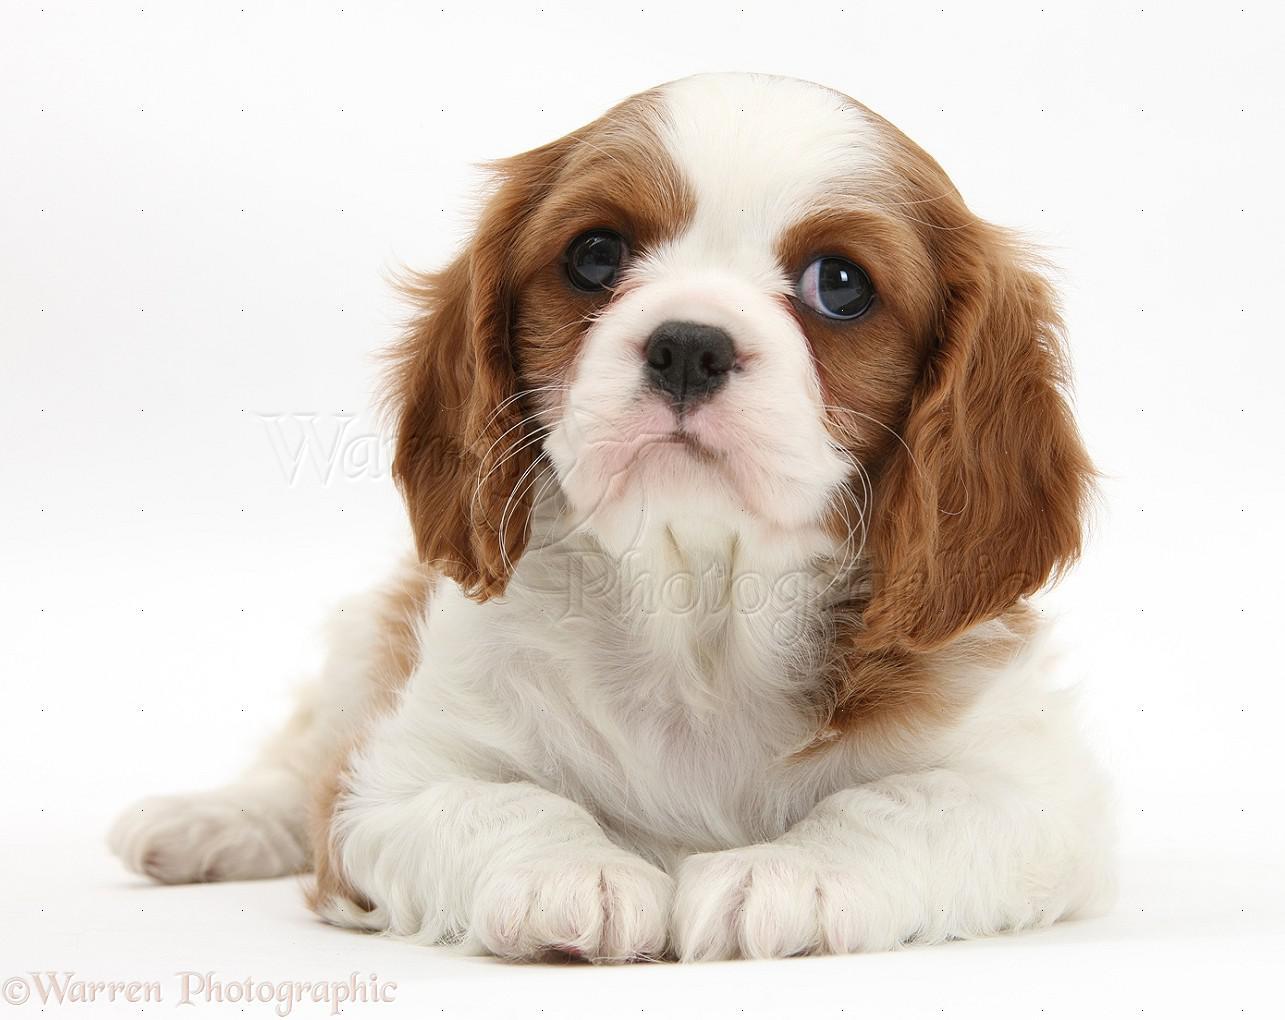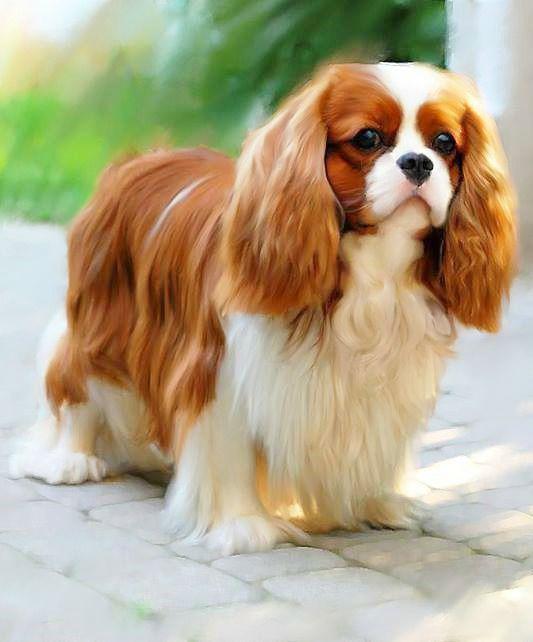The first image is the image on the left, the second image is the image on the right. Examine the images to the left and right. Is the description "One of the images contains a dog that is standing." accurate? Answer yes or no. Yes. 